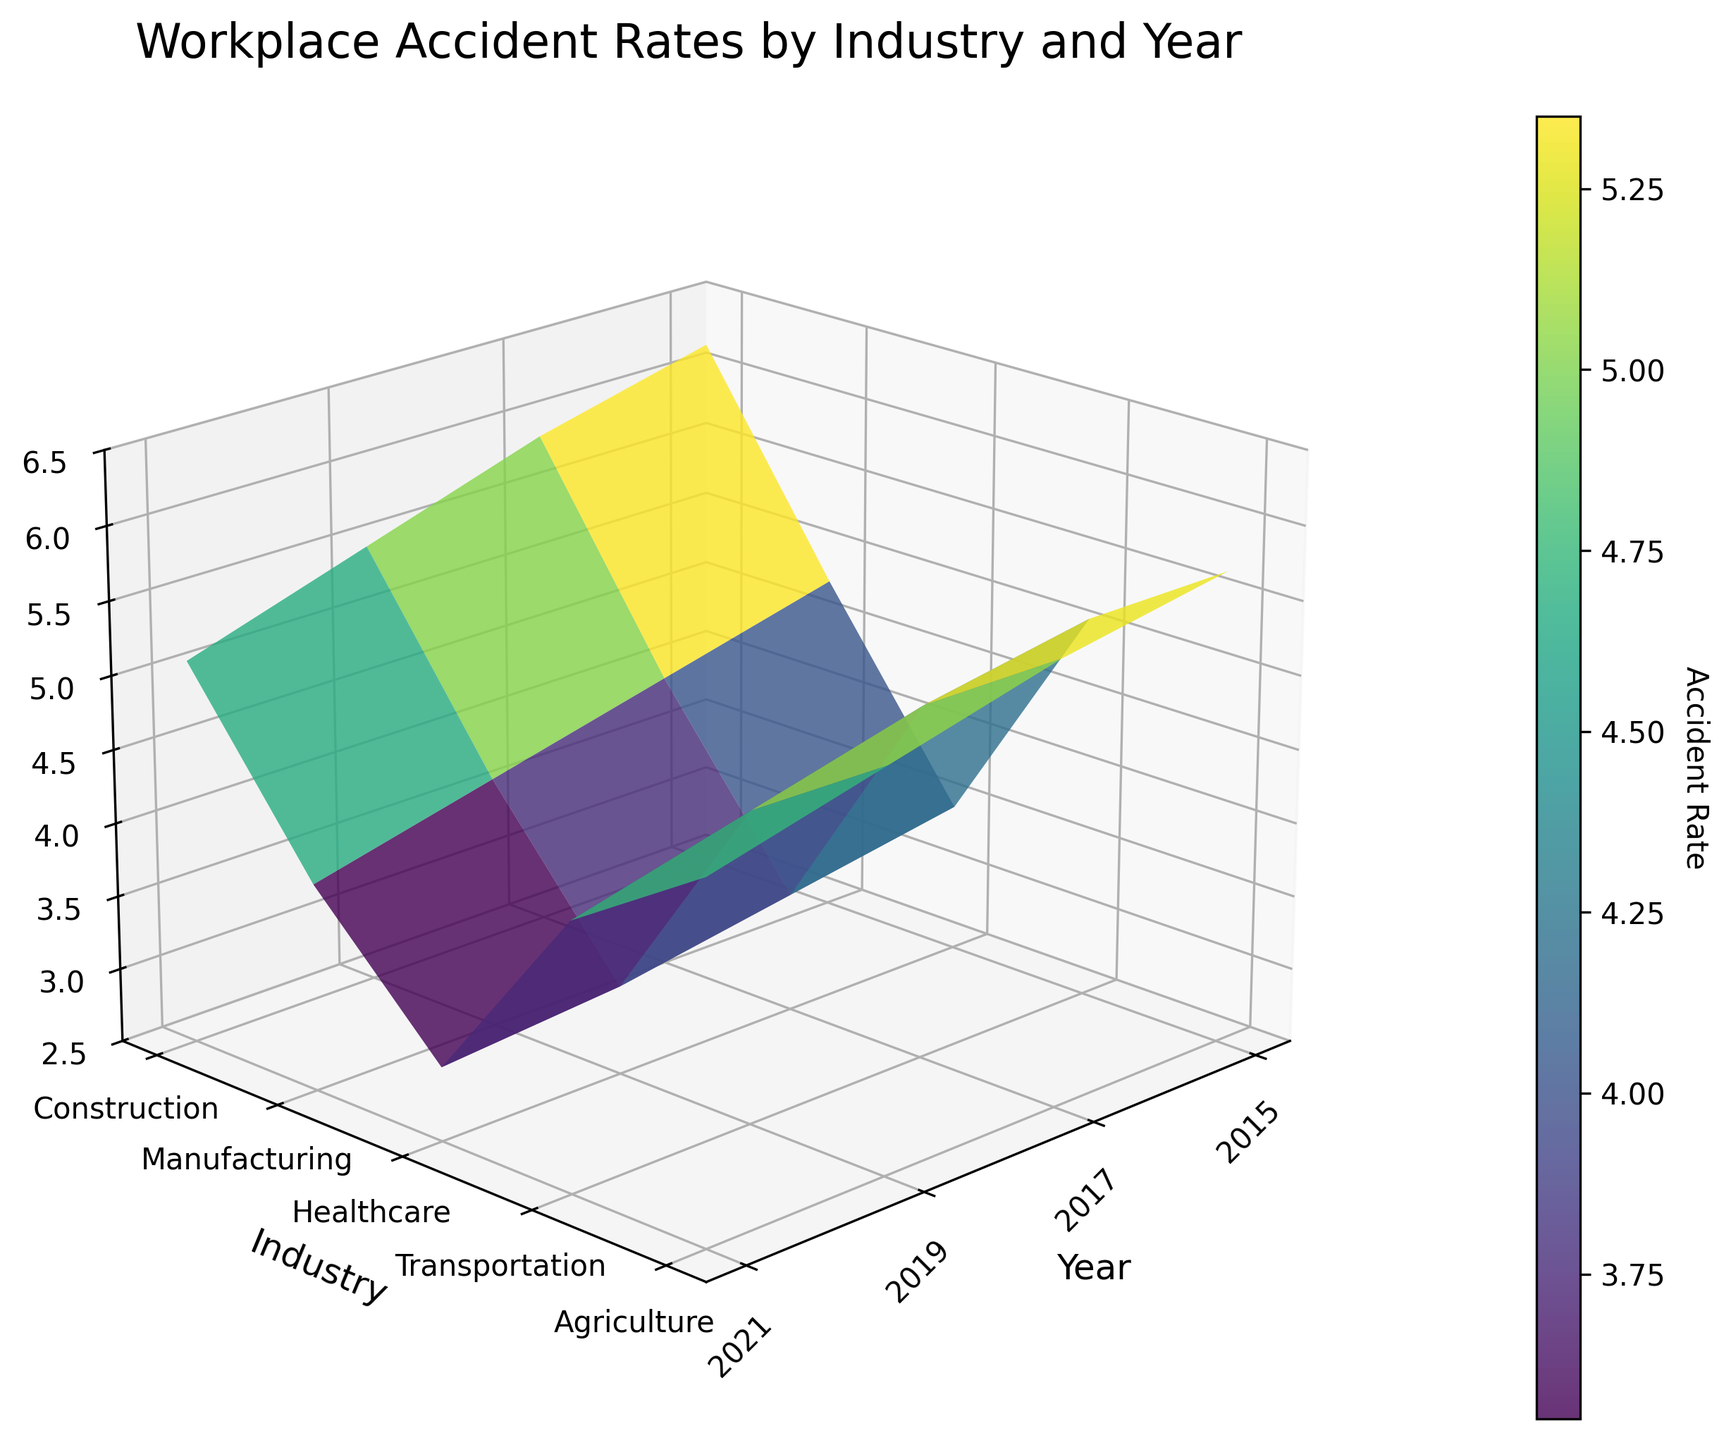What is the highest accident rate shown in the plot? Identify the z-axis and observe the peak points on the surface. The highest value on the z-axis represents the highest accident rate.
Answer: 6.2 Which industry shows a decreasing trend in accident rates from 2015 to 2021? Look at the distinct surface lines representing each industry, and observe the change in z-values (accident rates) over time for each industry.
Answer: Construction In which year did "Manufacturing" have the lowest accident rate? Identify the surface line for "Manufacturing" and find the year tick on the x-axis that corresponds to the lowest z-value on this line.
Answer: 2021 What is the range of accident rates for "Healthcare" during the given period? Observe the z-values of the surface line for "Healthcare" and calculate the difference between the highest and lowest points.
Answer: 3.5 - 3.0 Which two years had the highest and lowest accident rates for "Agriculture"? Identify the surface line for "Agriculture," then compare the z-values at different years, noting the highest and lowest values.
Answer: Highest: 2015, Lowest: 2021 How does the accident rate trend for "Transportation" compare to "Manufacturing" over time? Compare the surface lines for "Transportation" and "Manufacturing" by analyzing their z-values over different years and noting whether they increase, decrease, or remain constant.
Answer: Both decrease, but "Manufacturing" decreases more sharply What can you infer about job safety trends in the "Healthcare" industry from 2015 to 2021? Observe the change in z-values for the "Healthcare" surface line from 2015 to 2021, noting whether it rises, falls, or remains stable.
Answer: Improvement (rates decrease) Which industry had the most consistent accident rate over the years? Compare the variations in the surface lines' z-values for each industry. The industry with the least fluctuation is the most consistent.
Answer: Healthcare If you average the accident rates for "Truck Drivers" in 2015, 2017, 2019, and 2021, what value do you get? Note the z-values for "Transportation" in each year and calculate the average: (5.1 + 4.9 + 4.6 + 4.3) / 4.
Answer: 4.725 